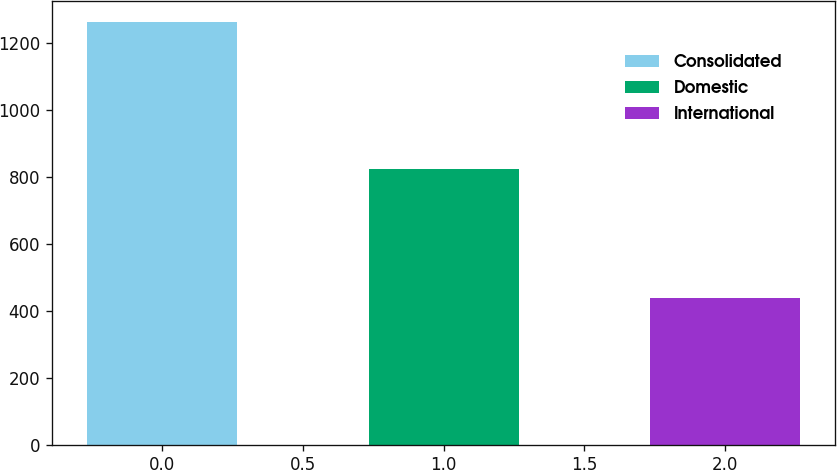<chart> <loc_0><loc_0><loc_500><loc_500><bar_chart><fcel>Consolidated<fcel>Domestic<fcel>International<nl><fcel>1264.1<fcel>824.6<fcel>439.5<nl></chart> 